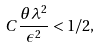<formula> <loc_0><loc_0><loc_500><loc_500>C \frac { \theta \lambda ^ { 2 } } { \epsilon ^ { 2 } } < 1 / 2 ,</formula> 